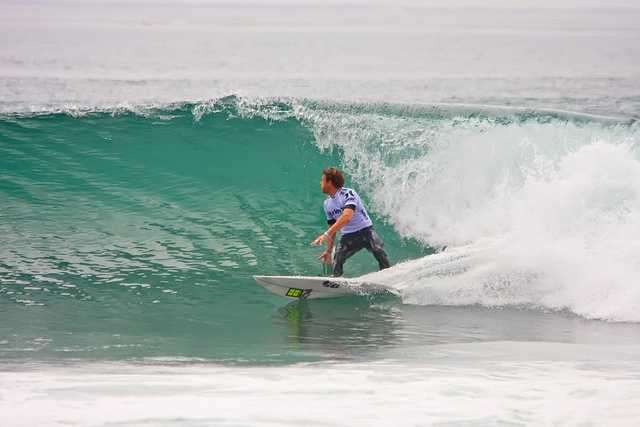Describe the objects in this image and their specific colors. I can see people in darkgray, black, and gray tones and surfboard in darkgray, gray, and lightgray tones in this image. 